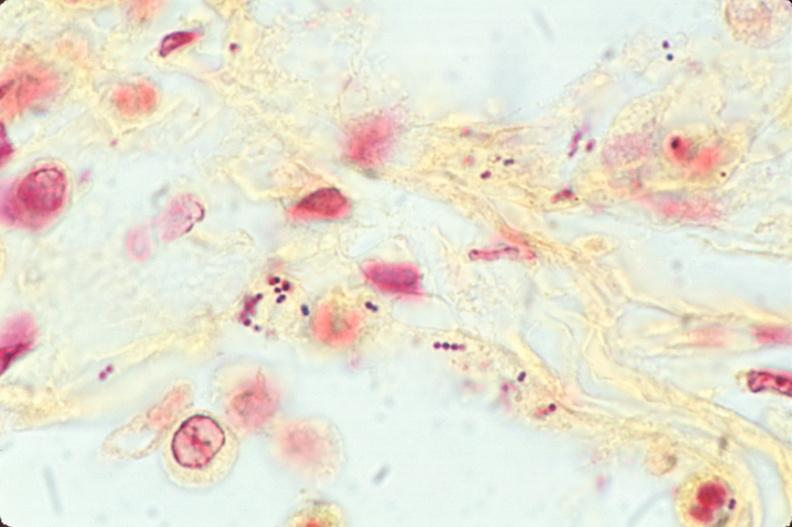where is this?
Answer the question using a single word or phrase. Lung 